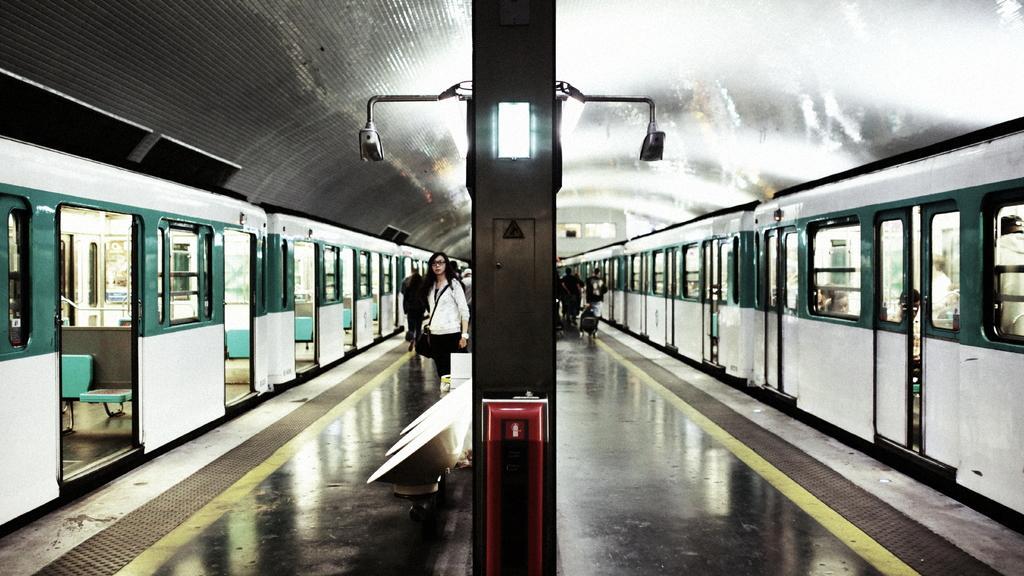Please provide a concise description of this image. In this picture there are people on the platform and we can see trains, lights attached to the pole, chairs and shed. 